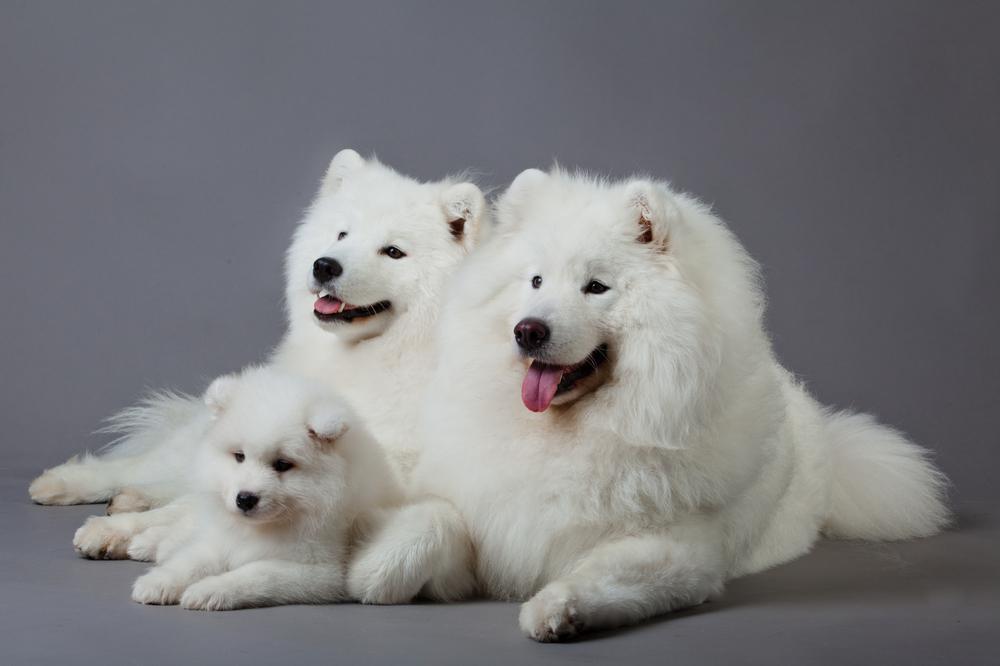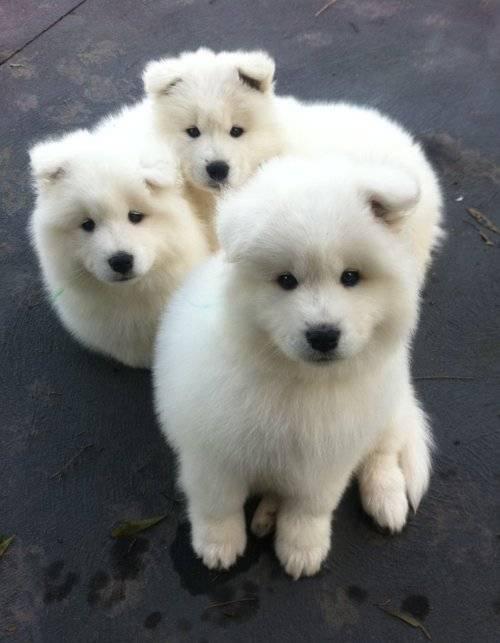The first image is the image on the left, the second image is the image on the right. For the images shown, is this caption "One image contains at least two dogs." true? Answer yes or no. Yes. The first image is the image on the left, the second image is the image on the right. Considering the images on both sides, is "There are at least two dogs in the image on the left" valid? Answer yes or no. Yes. 